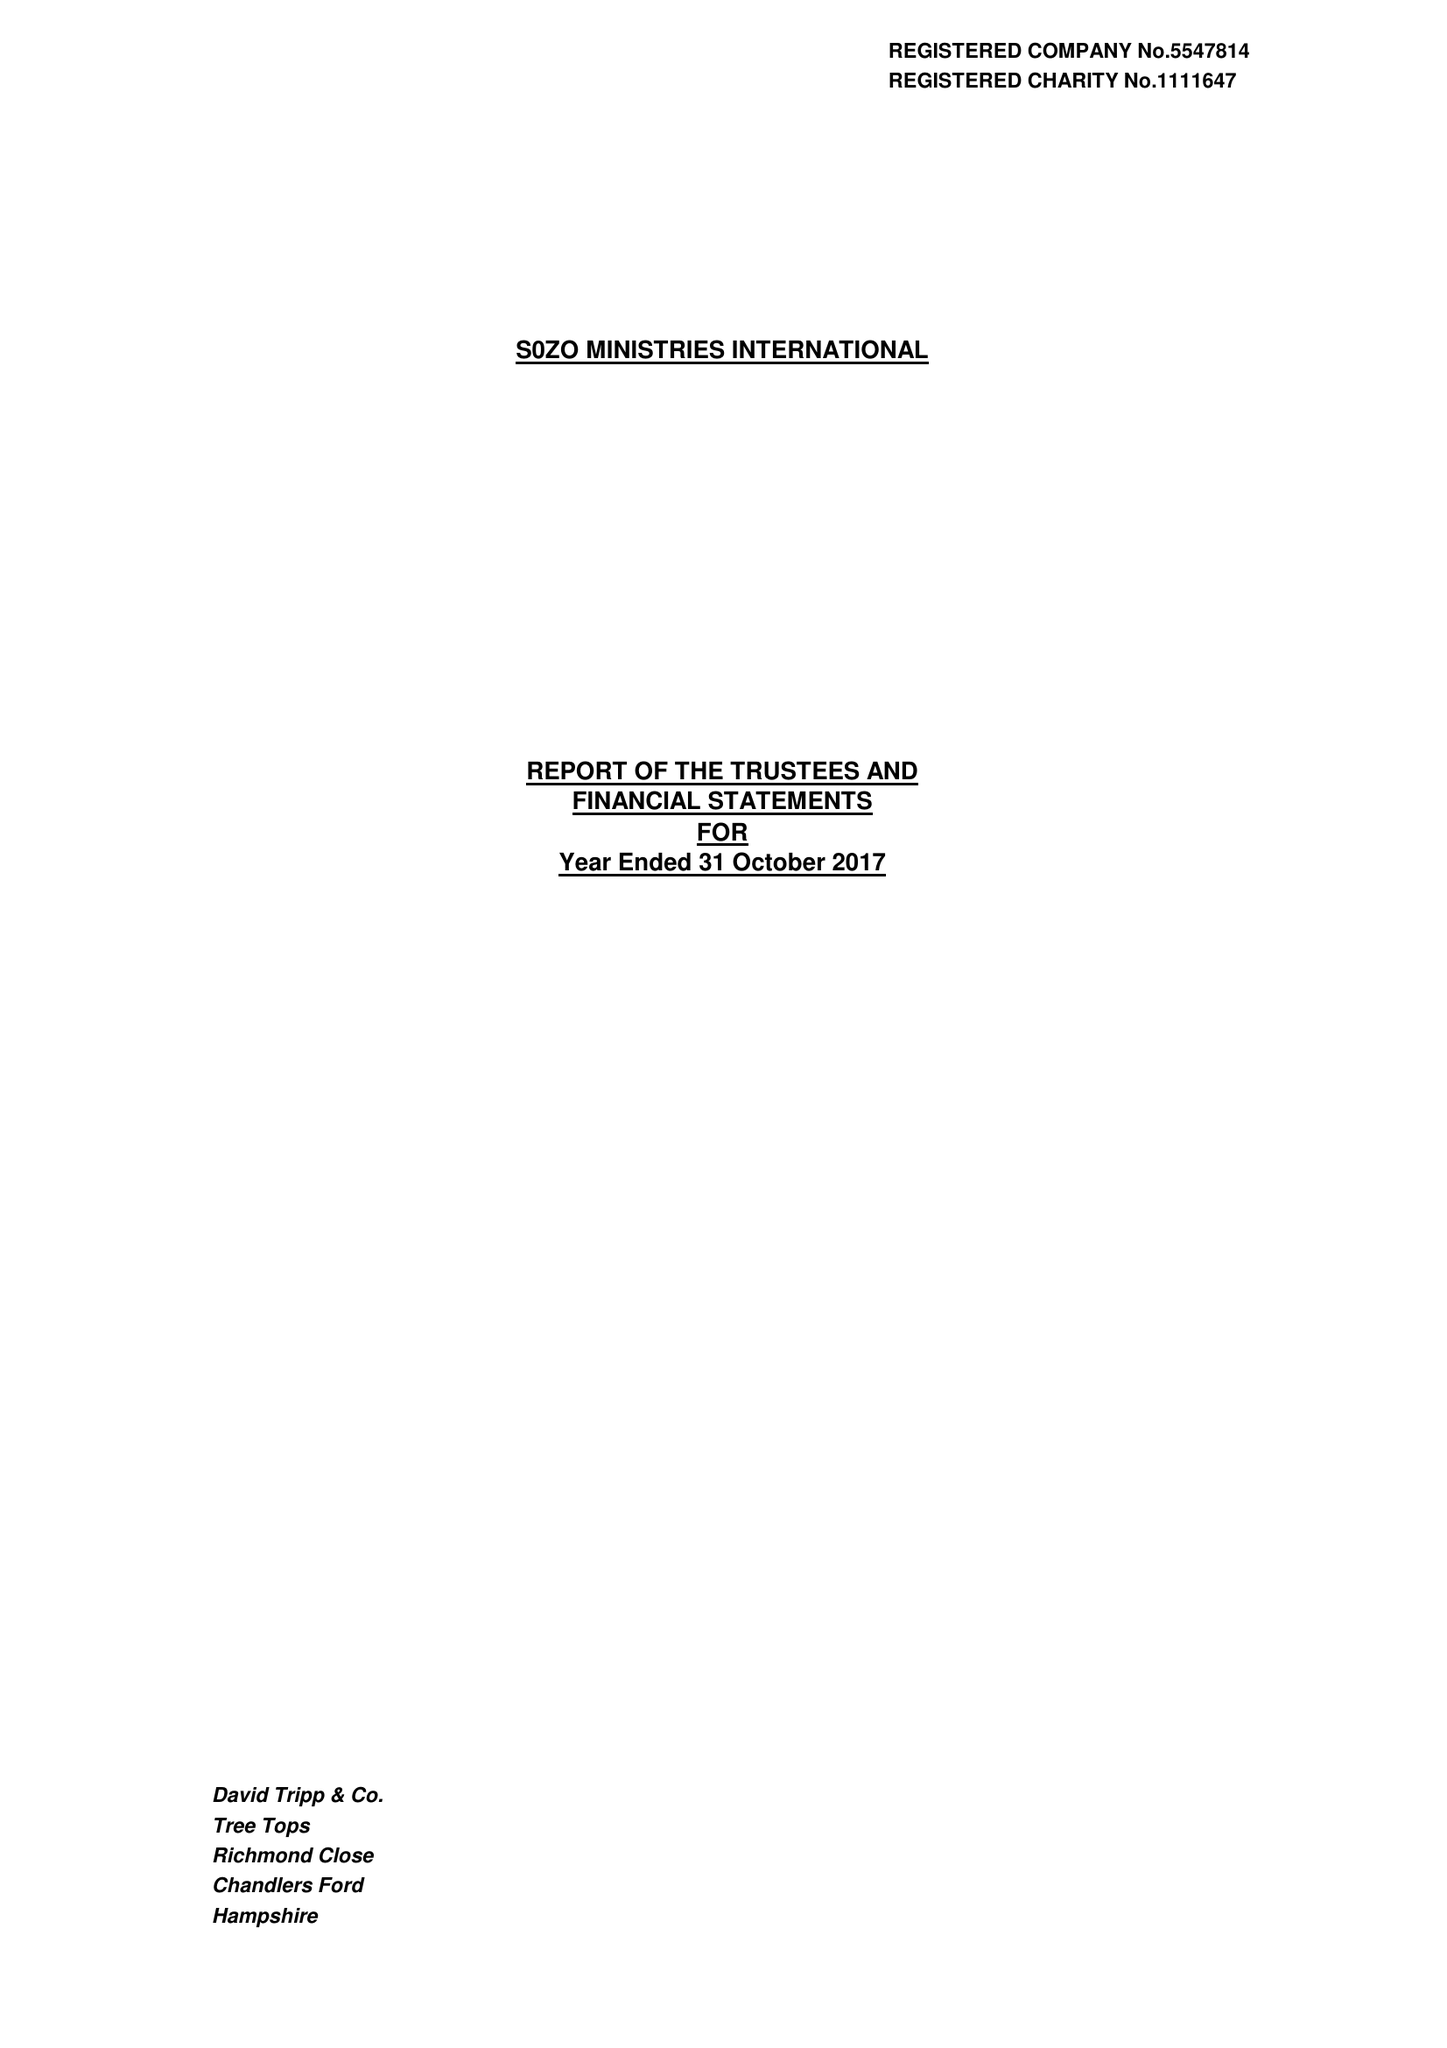What is the value for the income_annually_in_british_pounds?
Answer the question using a single word or phrase. 316737.00 